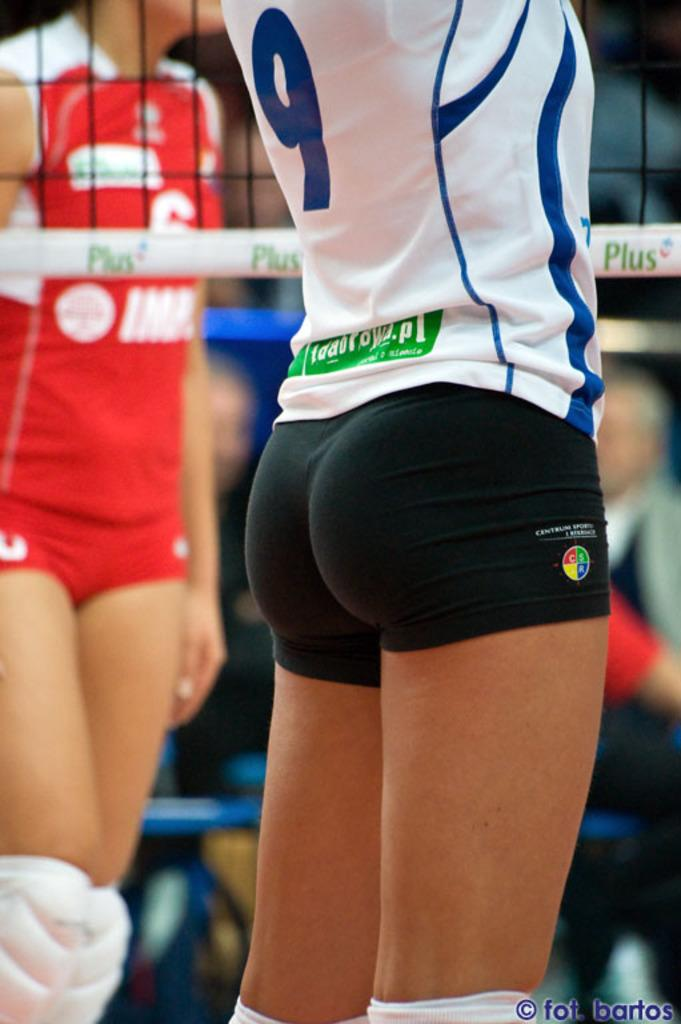<image>
Give a short and clear explanation of the subsequent image. Player 9 stands tall waiting for the game to start. 